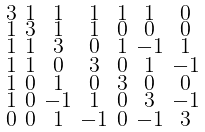Convert formula to latex. <formula><loc_0><loc_0><loc_500><loc_500>\begin{smallmatrix} 3 & 1 & 1 & 1 & 1 & 1 & 0 \\ 1 & 3 & 1 & 1 & 0 & 0 & 0 \\ 1 & 1 & 3 & 0 & 1 & - 1 & 1 \\ 1 & 1 & 0 & 3 & 0 & 1 & - 1 \\ 1 & 0 & 1 & 0 & 3 & 0 & 0 \\ 1 & 0 & - 1 & 1 & 0 & 3 & - 1 \\ 0 & 0 & 1 & - 1 & 0 & - 1 & 3 \end{smallmatrix}</formula> 